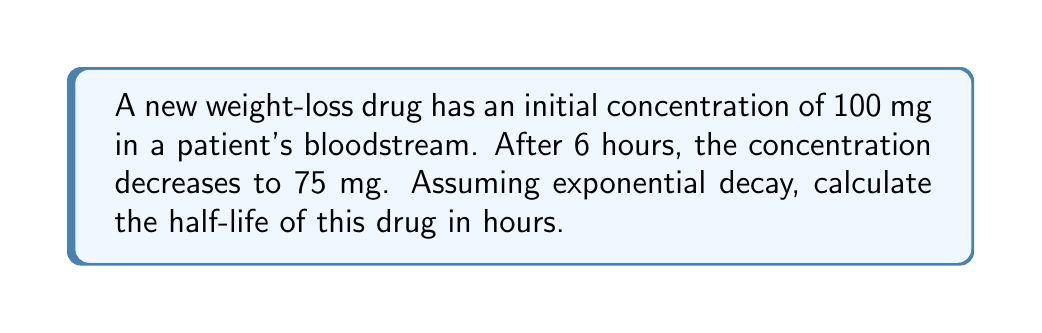Help me with this question. To solve this problem, we'll use the exponential decay formula and the given information to find the half-life of the drug.

1. The exponential decay formula is:
   $$ A(t) = A_0 e^{-\lambda t} $$
   where $A(t)$ is the amount at time $t$, $A_0$ is the initial amount, $\lambda$ is the decay constant, and $t$ is time.

2. We know:
   $A_0 = 100$ mg (initial concentration)
   $A(6) = 75$ mg (concentration after 6 hours)
   $t = 6$ hours

3. Substitute these values into the formula:
   $$ 75 = 100 e^{-6\lambda} $$

4. Solve for $\lambda$:
   $$ \frac{75}{100} = e^{-6\lambda} $$
   $$ \ln(0.75) = -6\lambda $$
   $$ \lambda = -\frac{\ln(0.75)}{6} \approx 0.0481 \text{ h}^{-1} $$

5. The half-life formula is:
   $$ t_{1/2} = \frac{\ln(2)}{\lambda} $$

6. Substitute the value of $\lambda$:
   $$ t_{1/2} = \frac{\ln(2)}{0.0481} \approx 14.41 \text{ hours} $$

Thus, the half-life of the weight-loss drug is approximately 14.41 hours.
Answer: 14.41 hours 